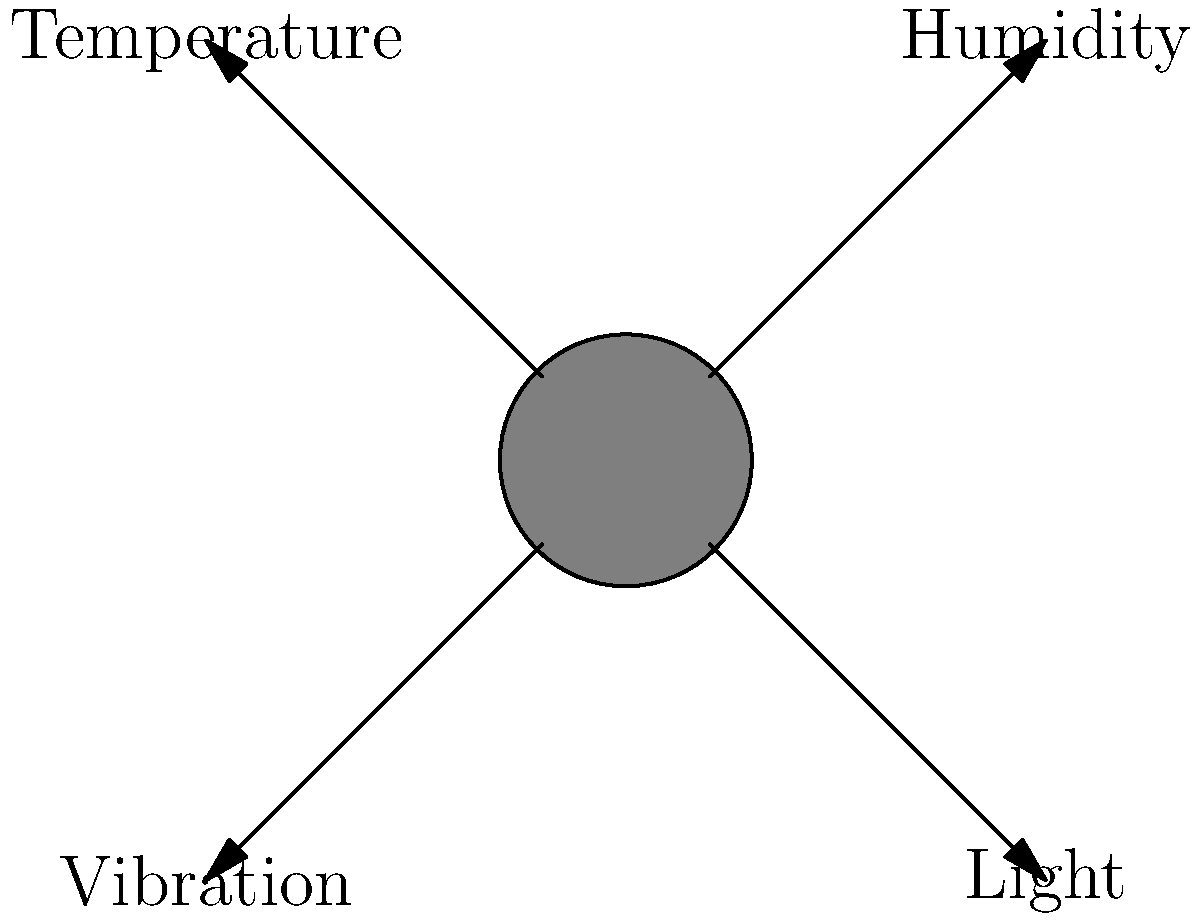Based on the diagram showing environmental factors affecting a sculpture, which factor is most likely to cause immediate physical damage to the artwork? To answer this question, let's analyze each environmental factor and its potential impact on the sculpture:

1. Humidity: High humidity can cause long-term damage through corrosion or mold growth, but it's not likely to cause immediate physical damage.

2. Temperature: Extreme temperatures or rapid changes can cause materials to expand or contract, potentially leading to cracks over time, but this is not an immediate threat.

3. Light: While prolonged exposure to light can cause fading or degradation of certain materials, it doesn't typically cause immediate physical damage.

4. Vibration: This factor stands out as the most likely to cause immediate physical damage. Vibrations can cause a sculpture to shift, fall, or even break apart, especially if it's fragile or not securely mounted.

Therefore, among the given factors, vibration poses the highest risk of immediate physical damage to the sculpture.
Answer: Vibration 